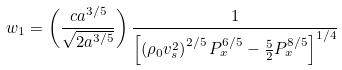Convert formula to latex. <formula><loc_0><loc_0><loc_500><loc_500>w _ { 1 } = \left ( \frac { c a ^ { 3 / 5 } } { \sqrt { 2 a ^ { 3 / 5 } } } \right ) \frac { 1 } { \left [ \left ( \rho _ { 0 } v _ { s } ^ { 2 } \right ) ^ { 2 / 5 } P _ { x } ^ { 6 / 5 } - \frac { 5 } { 2 } P _ { x } ^ { 8 / 5 } \right ] ^ { 1 / 4 } }</formula> 